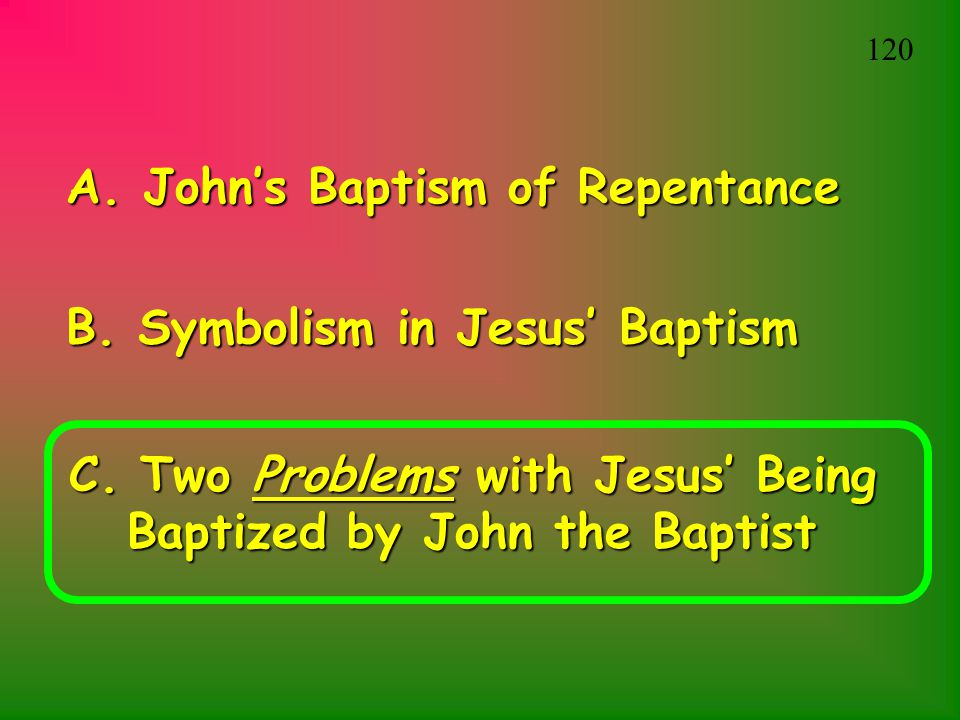What is the relationship between the three bullet points, and how might they contribute to the overall narrative of the presentation? The three bullet points establish a coherent framework for a detailed discussion on the Christian practice of baptism, focusing specifically on Jesus Christ. The first bullet point, 'John’s Baptism of Repentance,' sets the stage by providing historical context about baptism's origins and its role in repentance. This helps lay a foundational understanding for the audience. The second bullet point, 'Symbolism in Jesus' Baptism,' transitions the discussion to a deeper examination of the symbolic meanings and significance attached to Jesus' baptism. This likely explores themes of purification, divine approval, and initiation. The final bullet point, 'Two Problems with Jesus' Being Baptized by John the Baptist,' introduces a critical analysis, possibly addressing theological or doctrinal issues that may arise from the act of Jesus being baptized by John. It implies a nuanced exploration of potential controversies or differing interpretations within Christian thought. Together, these points suggest a thorough, multi-faceted exploration of baptism that combines historical, symbolic, and critical perspectives, aiming to provide a comprehensive understanding within the overall narrative of the presentation. 